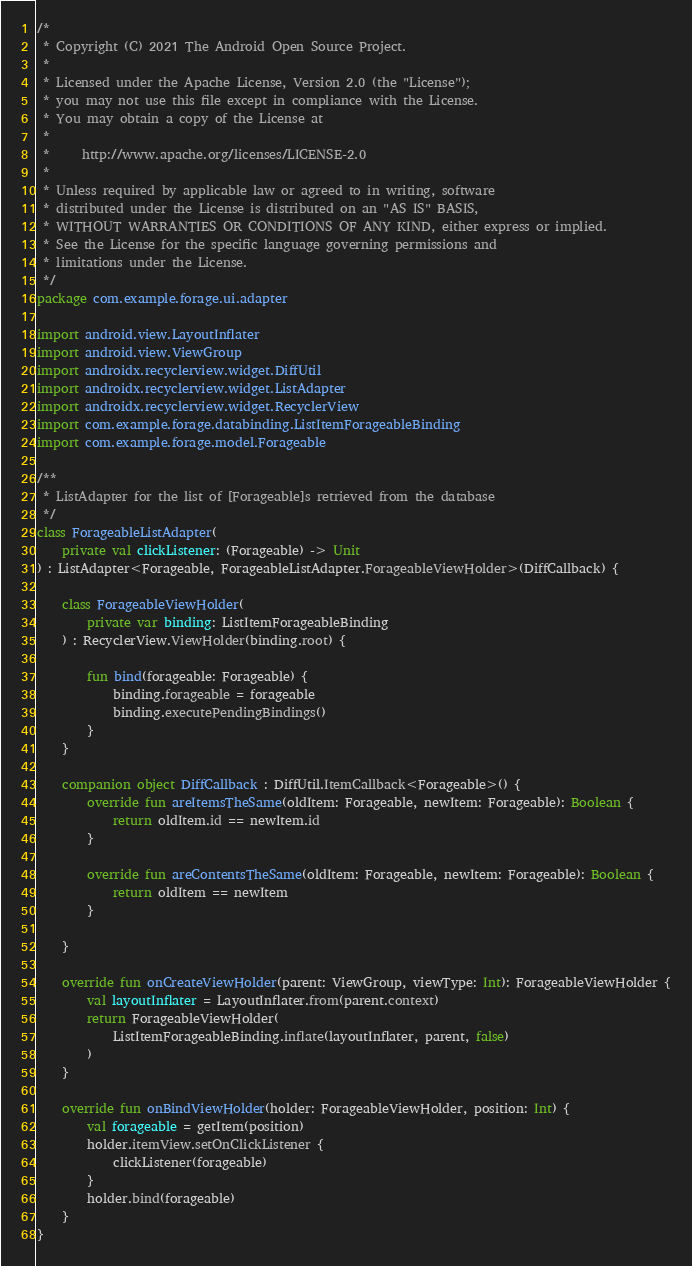Convert code to text. <code><loc_0><loc_0><loc_500><loc_500><_Kotlin_>/*
 * Copyright (C) 2021 The Android Open Source Project.
 *
 * Licensed under the Apache License, Version 2.0 (the "License");
 * you may not use this file except in compliance with the License.
 * You may obtain a copy of the License at
 *
 *     http://www.apache.org/licenses/LICENSE-2.0
 *
 * Unless required by applicable law or agreed to in writing, software
 * distributed under the License is distributed on an "AS IS" BASIS,
 * WITHOUT WARRANTIES OR CONDITIONS OF ANY KIND, either express or implied.
 * See the License for the specific language governing permissions and
 * limitations under the License.
 */
package com.example.forage.ui.adapter

import android.view.LayoutInflater
import android.view.ViewGroup
import androidx.recyclerview.widget.DiffUtil
import androidx.recyclerview.widget.ListAdapter
import androidx.recyclerview.widget.RecyclerView
import com.example.forage.databinding.ListItemForageableBinding
import com.example.forage.model.Forageable

/**
 * ListAdapter for the list of [Forageable]s retrieved from the database
 */
class ForageableListAdapter(
    private val clickListener: (Forageable) -> Unit
) : ListAdapter<Forageable, ForageableListAdapter.ForageableViewHolder>(DiffCallback) {

    class ForageableViewHolder(
        private var binding: ListItemForageableBinding
    ) : RecyclerView.ViewHolder(binding.root) {

        fun bind(forageable: Forageable) {
            binding.forageable = forageable
            binding.executePendingBindings()
        }
    }

    companion object DiffCallback : DiffUtil.ItemCallback<Forageable>() {
        override fun areItemsTheSame(oldItem: Forageable, newItem: Forageable): Boolean {
            return oldItem.id == newItem.id
        }

        override fun areContentsTheSame(oldItem: Forageable, newItem: Forageable): Boolean {
            return oldItem == newItem
        }

    }

    override fun onCreateViewHolder(parent: ViewGroup, viewType: Int): ForageableViewHolder {
        val layoutInflater = LayoutInflater.from(parent.context)
        return ForageableViewHolder(
            ListItemForageableBinding.inflate(layoutInflater, parent, false)
        )
    }

    override fun onBindViewHolder(holder: ForageableViewHolder, position: Int) {
        val forageable = getItem(position)
        holder.itemView.setOnClickListener {
            clickListener(forageable)
        }
        holder.bind(forageable)
    }
}
</code> 